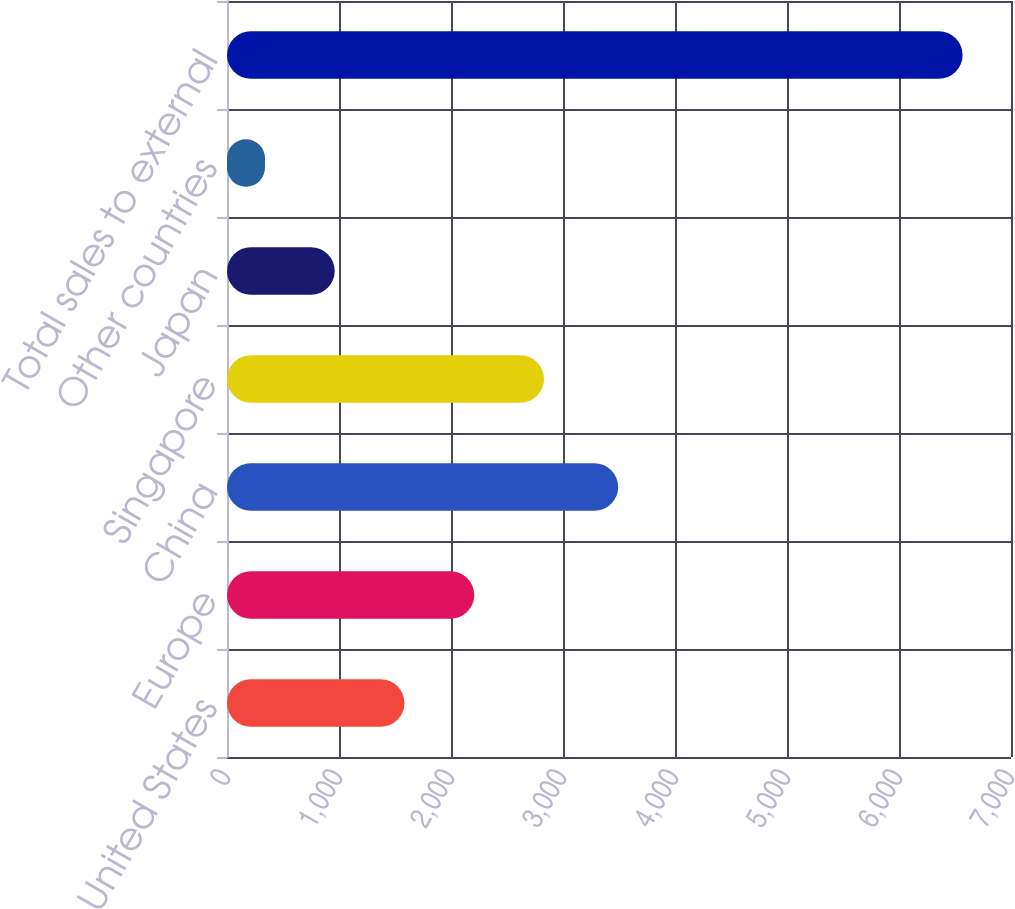Convert chart. <chart><loc_0><loc_0><loc_500><loc_500><bar_chart><fcel>United States<fcel>Europe<fcel>China<fcel>Singapore<fcel>Japan<fcel>Other countries<fcel>Total sales to external<nl><fcel>1584.8<fcel>2207.7<fcel>3493<fcel>2830.6<fcel>961.9<fcel>339<fcel>6568<nl></chart> 